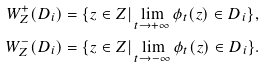Convert formula to latex. <formula><loc_0><loc_0><loc_500><loc_500>W ^ { + } _ { Z } ( D _ { i } ) & = \{ z \in Z | \lim _ { t \rightarrow + \infty } \phi _ { t } ( z ) \in D _ { i } \} , \\ W ^ { - } _ { Z } ( D _ { i } ) & = \{ z \in Z | \lim _ { t \rightarrow - \infty } \phi _ { t } ( z ) \in D _ { i } \} .</formula> 